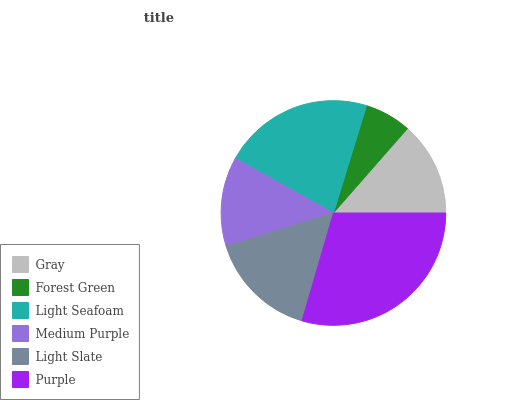Is Forest Green the minimum?
Answer yes or no. Yes. Is Purple the maximum?
Answer yes or no. Yes. Is Light Seafoam the minimum?
Answer yes or no. No. Is Light Seafoam the maximum?
Answer yes or no. No. Is Light Seafoam greater than Forest Green?
Answer yes or no. Yes. Is Forest Green less than Light Seafoam?
Answer yes or no. Yes. Is Forest Green greater than Light Seafoam?
Answer yes or no. No. Is Light Seafoam less than Forest Green?
Answer yes or no. No. Is Light Slate the high median?
Answer yes or no. Yes. Is Gray the low median?
Answer yes or no. Yes. Is Light Seafoam the high median?
Answer yes or no. No. Is Light Slate the low median?
Answer yes or no. No. 